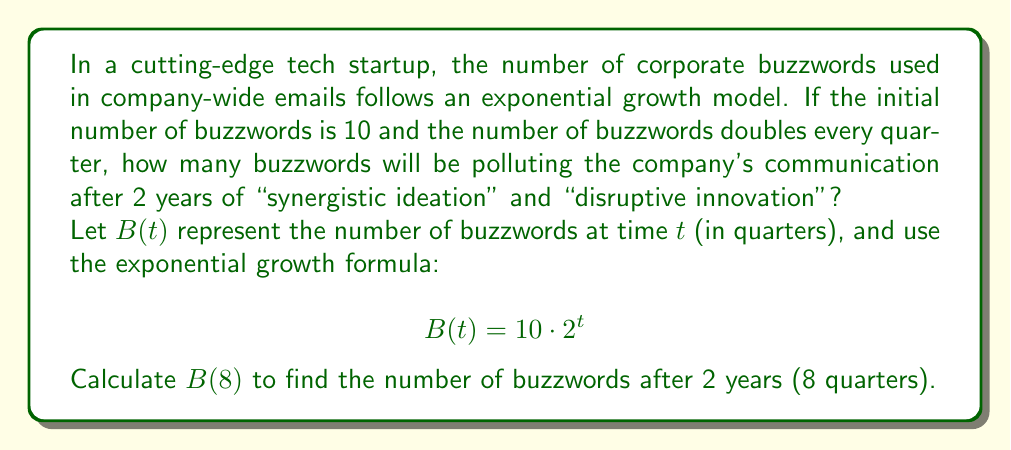What is the answer to this math problem? Let's break this down step-by-step:

1) We're given the exponential growth formula:
   $$B(t) = 10 \cdot 2^t$$

2) We need to calculate $B(8)$ since 2 years = 8 quarters:
   $$B(8) = 10 \cdot 2^8$$

3) Let's evaluate $2^8$:
   $$2^8 = 2 \cdot 2 \cdot 2 \cdot 2 \cdot 2 \cdot 2 \cdot 2 \cdot 2 = 256$$

4) Now we can complete the calculation:
   $$B(8) = 10 \cdot 256 = 2560$$

Thus, after 2 years of exponential growth, the company's emails will be drowning in 2,560 buzzwords, creating a veritable "paradigm shift" in incomprehensibility.
Answer: 2,560 buzzwords 